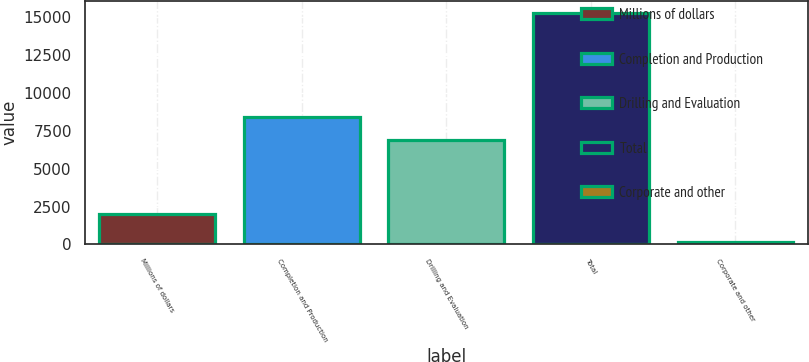Convert chart to OTSL. <chart><loc_0><loc_0><loc_500><loc_500><bar_chart><fcel>Millions of dollars<fcel>Completion and Production<fcel>Drilling and Evaluation<fcel>Total<fcel>Corporate and other<nl><fcel>2007<fcel>8386<fcel>6878<fcel>15264<fcel>186<nl></chart> 